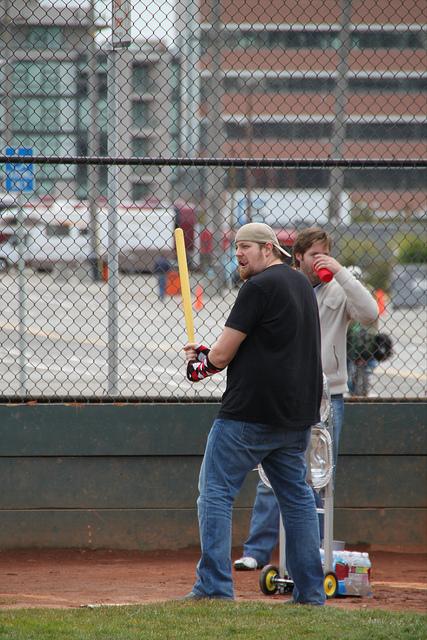What is the man holding?
Give a very brief answer. Bat. What color is the mans cup?
Write a very short answer. Red. Which direction is the man's hat facing?
Short answer required. Backwards. 